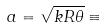Convert formula to latex. <formula><loc_0><loc_0><loc_500><loc_500>a = \sqrt { k R \theta } \equiv</formula> 